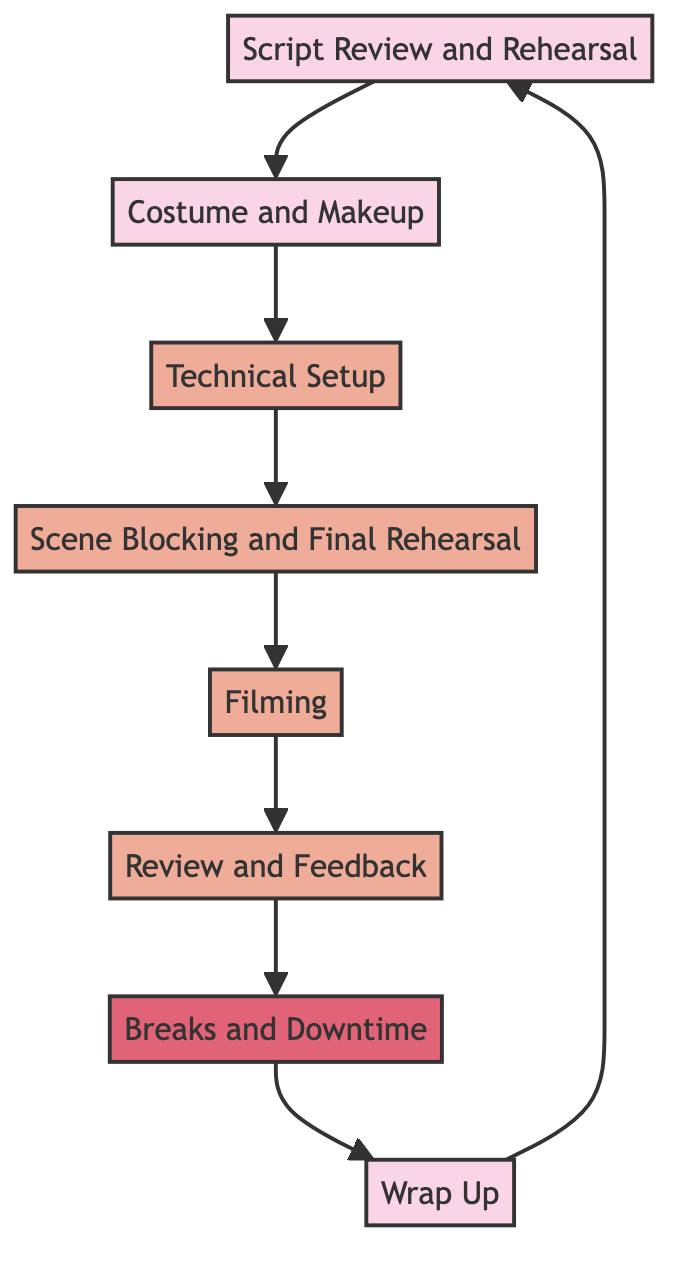What is the first step in the workflow? The first step listed in the diagram is "Script Review and Rehearsal," which indicates that Tye Sheridan starts his day by reviewing the script and rehearsing his scenes with the director.
Answer: Script Review and Rehearsal How many steps are there in the workflow? By counting all the distinct elements listed in the diagram, there are a total of eight steps that Tye Sheridan goes through.
Answer: Eight Which step comes after "Filming"? The diagram shows that "Review and Feedback" is the step that follows "Filming," indicating the process of reviewing the takes.
Answer: Review and Feedback What is the last step in the workflow before returning to the start? The last step before looping back to the start is "Wrap Up," which signifies the conclusion of the day's shoot and input for post-production.
Answer: Wrap Up In what step does Tye Sheridan take scheduled breaks? Based on the diagram, "Breaks and Downtime" is the designated step for Tye Sheridan to take breaks and rest, indicating a scheduled pause in the workflow.
Answer: Breaks and Downtime What kind of tasks are involved in the "Technical Setup"? The "Technical Setup" involves setting up lighting, sound, and camera equipment, which are essential for the filming process.
Answer: Lighting, sound, camera setup How is "Scene Blocking and Final Rehearsal" related to "Filming"? The diagram indicates that "Scene Blocking and Final Rehearsal" directly precedes "Filming," showing that all staging and rehearsal work is completed before actual filming occurs.
Answer: Directly precedes What does the workflow cycle back to after "Wrap Up"? After "Wrap Up," the workflow cycles back to "Script Review and Rehearsal," indicating a continuous process where Tye Sheridan prepares for future scenes.
Answer: Script Review and Rehearsal 